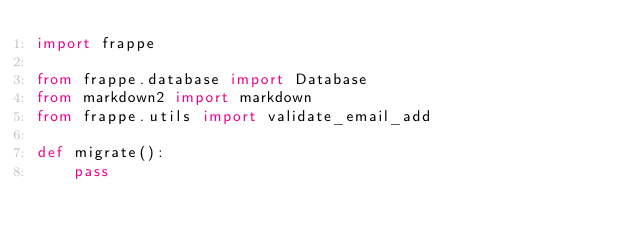<code> <loc_0><loc_0><loc_500><loc_500><_Python_>import frappe

from frappe.database import Database
from markdown2 import markdown
from frappe.utils import validate_email_add

def migrate():
	pass
</code> 